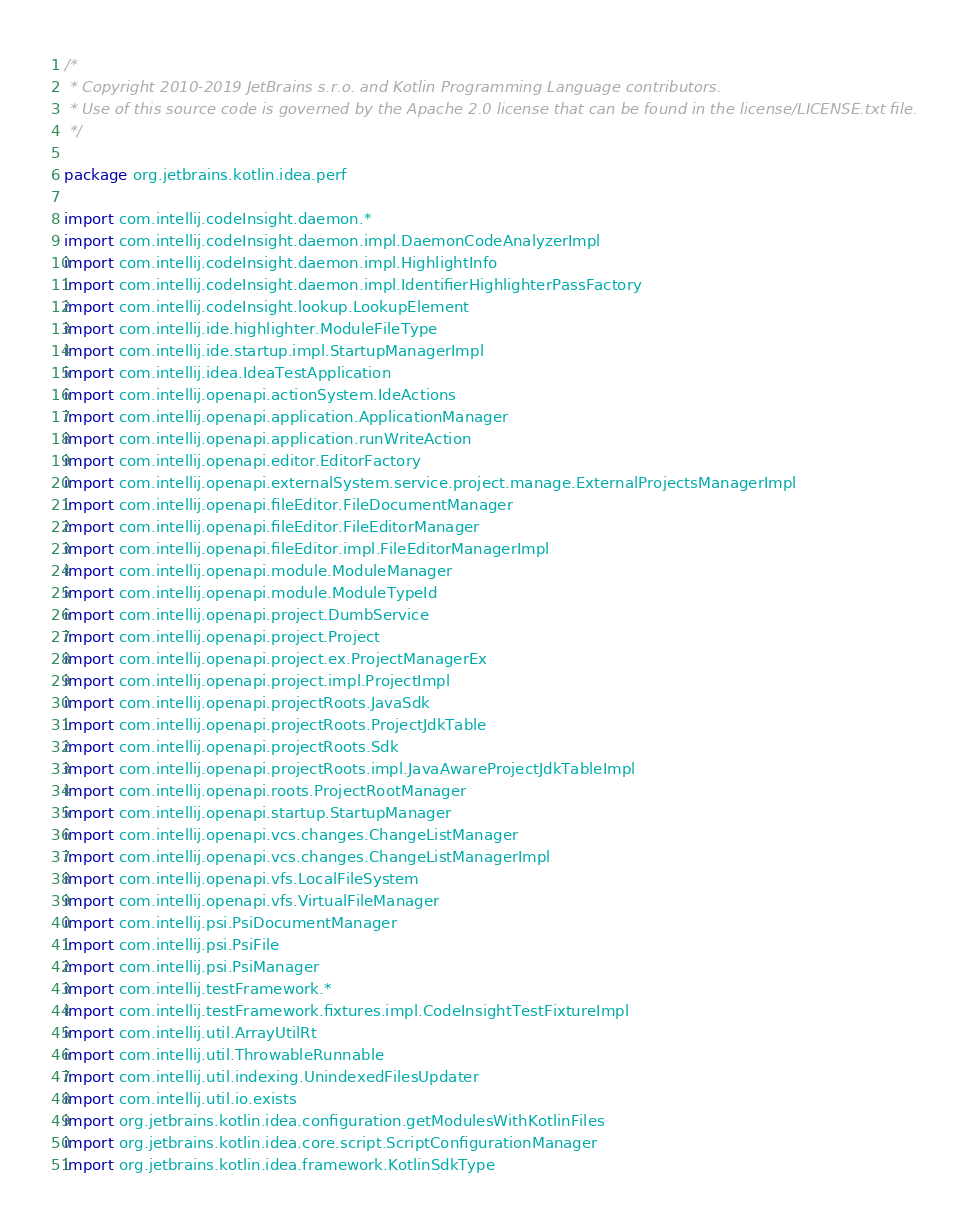Convert code to text. <code><loc_0><loc_0><loc_500><loc_500><_Kotlin_>/*
 * Copyright 2010-2019 JetBrains s.r.o. and Kotlin Programming Language contributors.
 * Use of this source code is governed by the Apache 2.0 license that can be found in the license/LICENSE.txt file.
 */

package org.jetbrains.kotlin.idea.perf

import com.intellij.codeInsight.daemon.*
import com.intellij.codeInsight.daemon.impl.DaemonCodeAnalyzerImpl
import com.intellij.codeInsight.daemon.impl.HighlightInfo
import com.intellij.codeInsight.daemon.impl.IdentifierHighlighterPassFactory
import com.intellij.codeInsight.lookup.LookupElement
import com.intellij.ide.highlighter.ModuleFileType
import com.intellij.ide.startup.impl.StartupManagerImpl
import com.intellij.idea.IdeaTestApplication
import com.intellij.openapi.actionSystem.IdeActions
import com.intellij.openapi.application.ApplicationManager
import com.intellij.openapi.application.runWriteAction
import com.intellij.openapi.editor.EditorFactory
import com.intellij.openapi.externalSystem.service.project.manage.ExternalProjectsManagerImpl
import com.intellij.openapi.fileEditor.FileDocumentManager
import com.intellij.openapi.fileEditor.FileEditorManager
import com.intellij.openapi.fileEditor.impl.FileEditorManagerImpl
import com.intellij.openapi.module.ModuleManager
import com.intellij.openapi.module.ModuleTypeId
import com.intellij.openapi.project.DumbService
import com.intellij.openapi.project.Project
import com.intellij.openapi.project.ex.ProjectManagerEx
import com.intellij.openapi.project.impl.ProjectImpl
import com.intellij.openapi.projectRoots.JavaSdk
import com.intellij.openapi.projectRoots.ProjectJdkTable
import com.intellij.openapi.projectRoots.Sdk
import com.intellij.openapi.projectRoots.impl.JavaAwareProjectJdkTableImpl
import com.intellij.openapi.roots.ProjectRootManager
import com.intellij.openapi.startup.StartupManager
import com.intellij.openapi.vcs.changes.ChangeListManager
import com.intellij.openapi.vcs.changes.ChangeListManagerImpl
import com.intellij.openapi.vfs.LocalFileSystem
import com.intellij.openapi.vfs.VirtualFileManager
import com.intellij.psi.PsiDocumentManager
import com.intellij.psi.PsiFile
import com.intellij.psi.PsiManager
import com.intellij.testFramework.*
import com.intellij.testFramework.fixtures.impl.CodeInsightTestFixtureImpl
import com.intellij.util.ArrayUtilRt
import com.intellij.util.ThrowableRunnable
import com.intellij.util.indexing.UnindexedFilesUpdater
import com.intellij.util.io.exists
import org.jetbrains.kotlin.idea.configuration.getModulesWithKotlinFiles
import org.jetbrains.kotlin.idea.core.script.ScriptConfigurationManager
import org.jetbrains.kotlin.idea.framework.KotlinSdkType</code> 